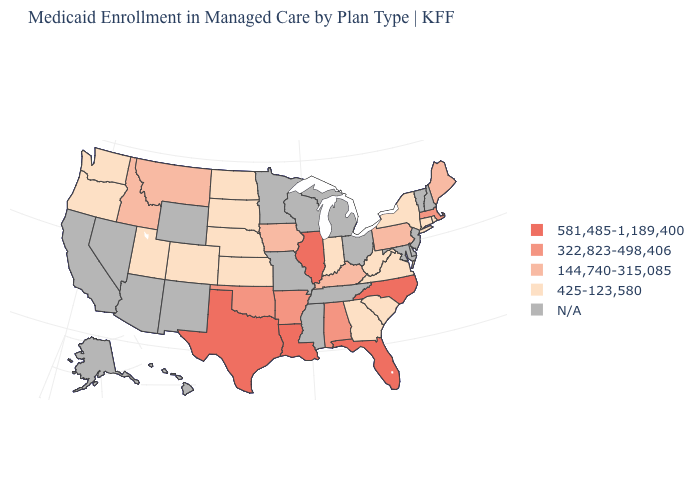What is the value of Georgia?
Give a very brief answer. 425-123,580. Is the legend a continuous bar?
Quick response, please. No. Does the first symbol in the legend represent the smallest category?
Answer briefly. No. Name the states that have a value in the range 144,740-315,085?
Give a very brief answer. Idaho, Iowa, Kentucky, Maine, Montana, Pennsylvania. What is the lowest value in the USA?
Be succinct. 425-123,580. What is the highest value in the Northeast ?
Short answer required. 322,823-498,406. Name the states that have a value in the range 581,485-1,189,400?
Answer briefly. Florida, Illinois, Louisiana, North Carolina, Texas. Is the legend a continuous bar?
Give a very brief answer. No. Name the states that have a value in the range 425-123,580?
Short answer required. Colorado, Connecticut, Georgia, Indiana, Kansas, Nebraska, New York, North Dakota, Oregon, Rhode Island, South Carolina, South Dakota, Utah, Virginia, Washington, West Virginia. Does the map have missing data?
Concise answer only. Yes. Does West Virginia have the lowest value in the South?
Short answer required. Yes. Among the states that border Utah , which have the highest value?
Quick response, please. Idaho. 